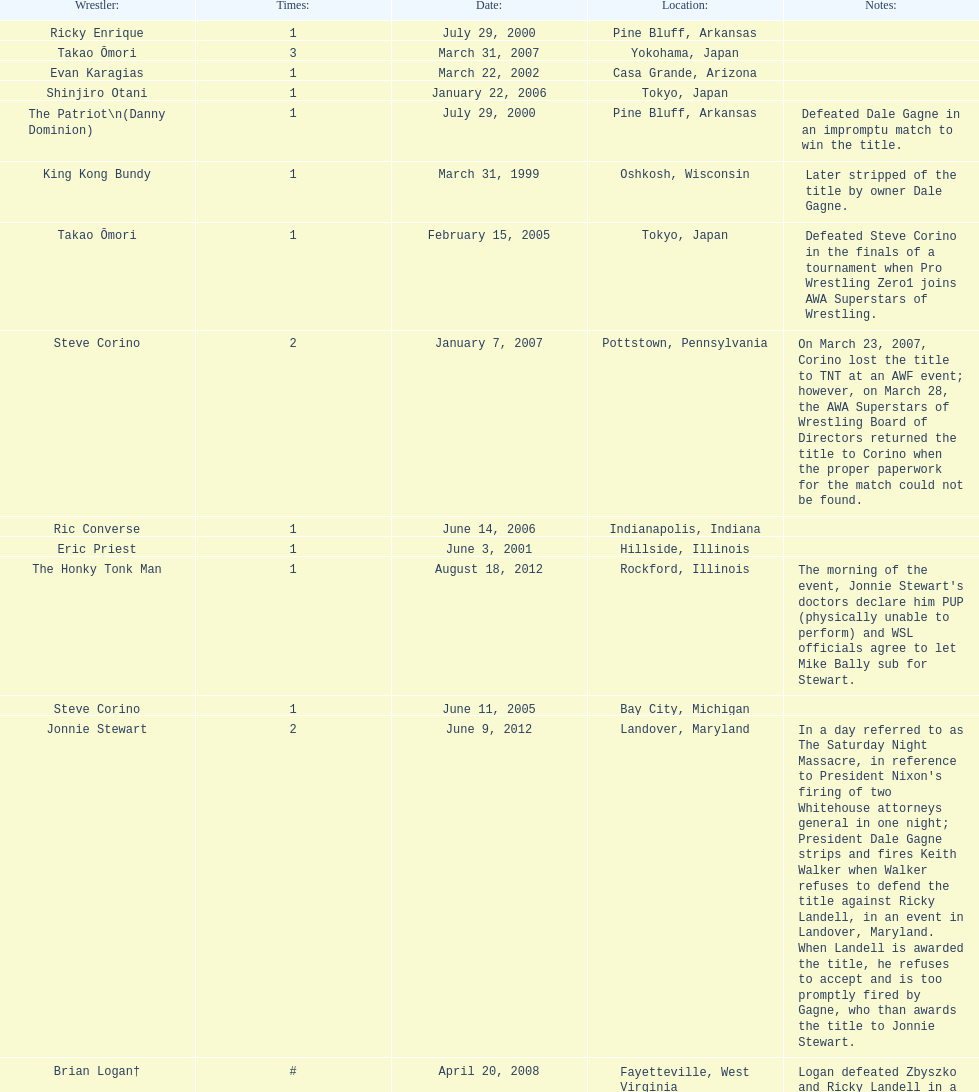What are the number of matches that happened in japan? 5. 